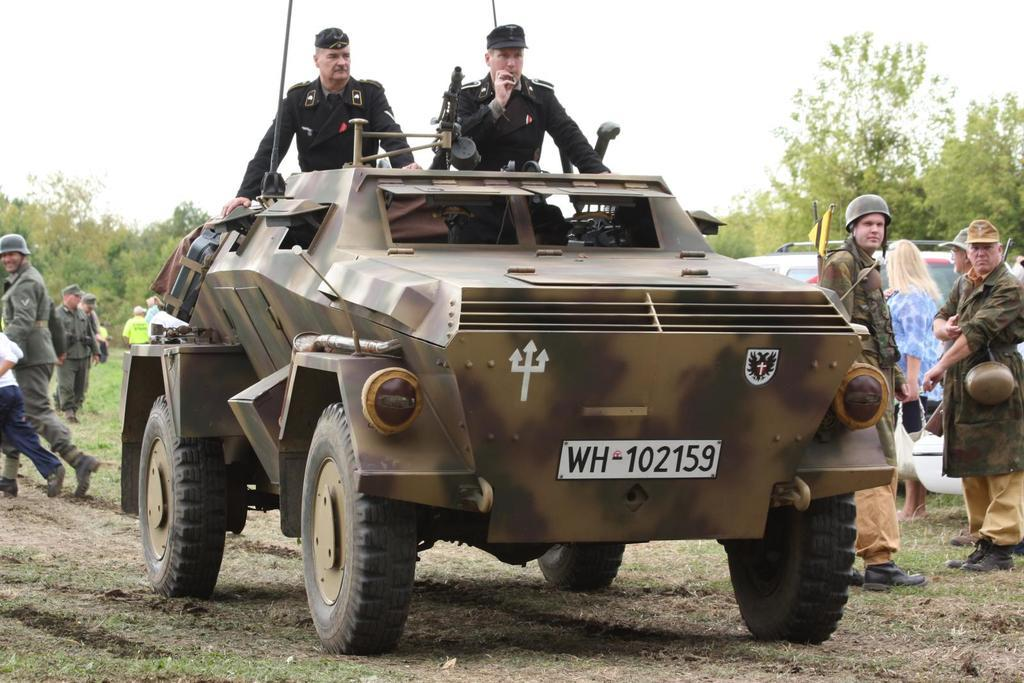What is the main subject of the image? There is a vehicle in the image. Who is present near the vehicle? Two persons are standing near the vehicle. What are the two persons wearing? The two persons are wearing dresses. Can you describe the woman on the right side of the image? The woman is wearing a blue color dress. What type of vegetation can be seen in the image? There are green trees in the image. What type of spacecraft can be seen in the image? There is no spacecraft present in the image; it features a vehicle on the ground. What kind of yarn is being used to knit the loaf in the image? There is no loaf or yarn present in the image. 